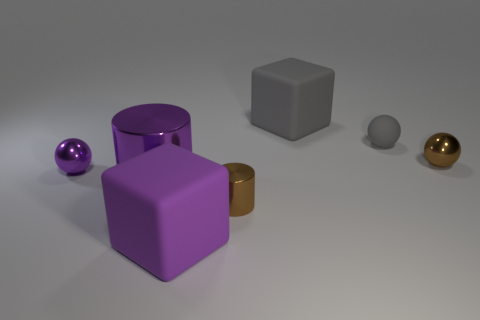Subtract all red balls. Subtract all blue cubes. How many balls are left? 3 Add 2 large purple shiny things. How many objects exist? 9 Subtract all cylinders. How many objects are left? 5 Subtract all tiny purple matte cubes. Subtract all purple cylinders. How many objects are left? 6 Add 4 metal cylinders. How many metal cylinders are left? 6 Add 3 large purple cylinders. How many large purple cylinders exist? 4 Subtract 0 yellow cubes. How many objects are left? 7 